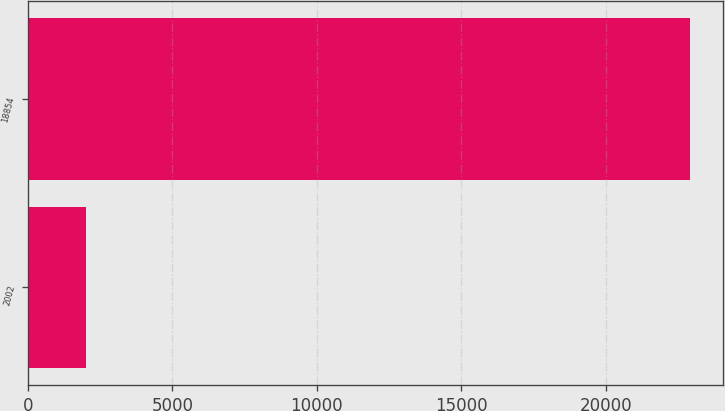<chart> <loc_0><loc_0><loc_500><loc_500><bar_chart><fcel>2002<fcel>18854<nl><fcel>2000<fcel>22907<nl></chart> 